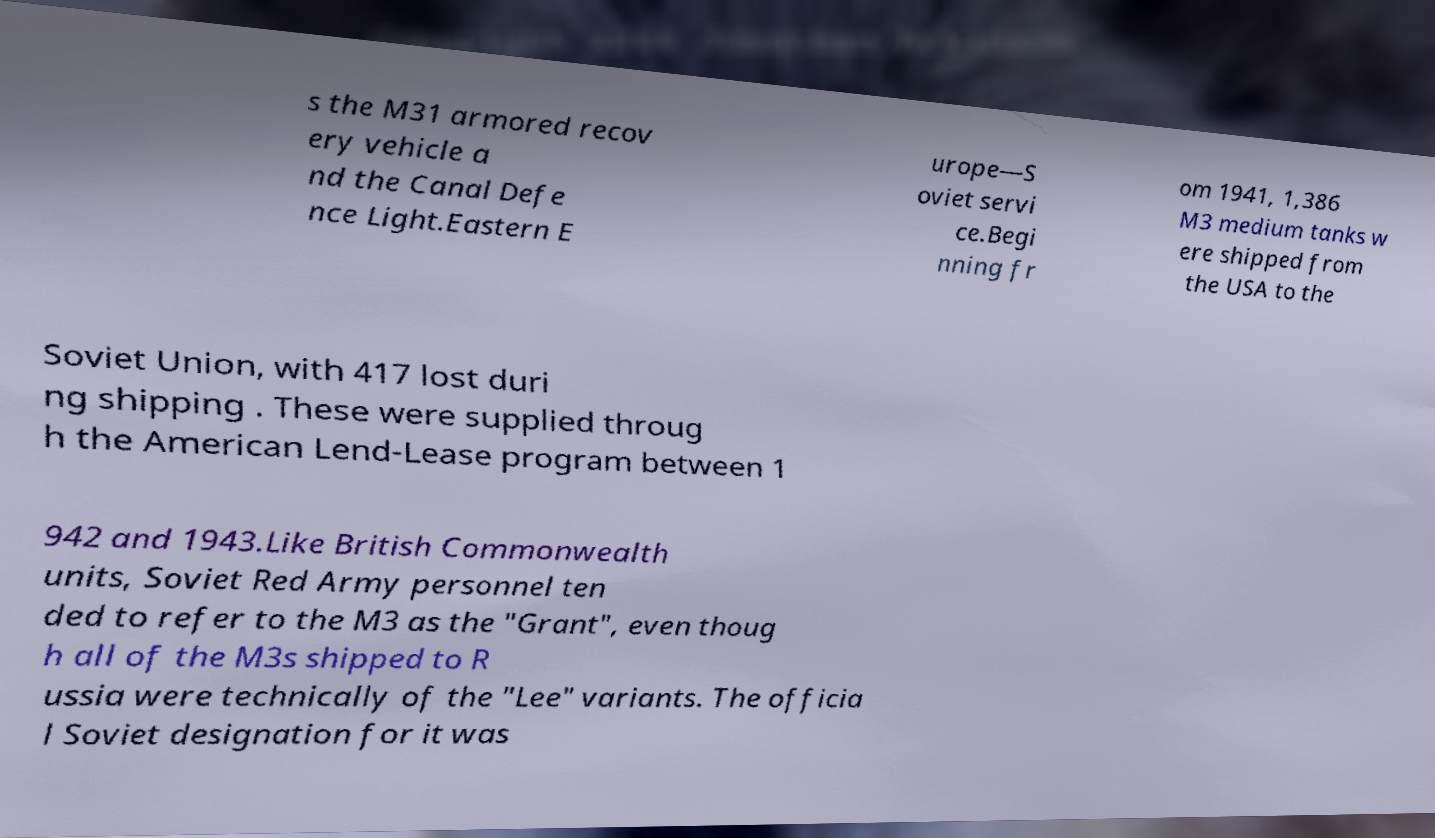Please identify and transcribe the text found in this image. s the M31 armored recov ery vehicle a nd the Canal Defe nce Light.Eastern E urope—S oviet servi ce.Begi nning fr om 1941, 1,386 M3 medium tanks w ere shipped from the USA to the Soviet Union, with 417 lost duri ng shipping . These were supplied throug h the American Lend-Lease program between 1 942 and 1943.Like British Commonwealth units, Soviet Red Army personnel ten ded to refer to the M3 as the "Grant", even thoug h all of the M3s shipped to R ussia were technically of the "Lee" variants. The officia l Soviet designation for it was 